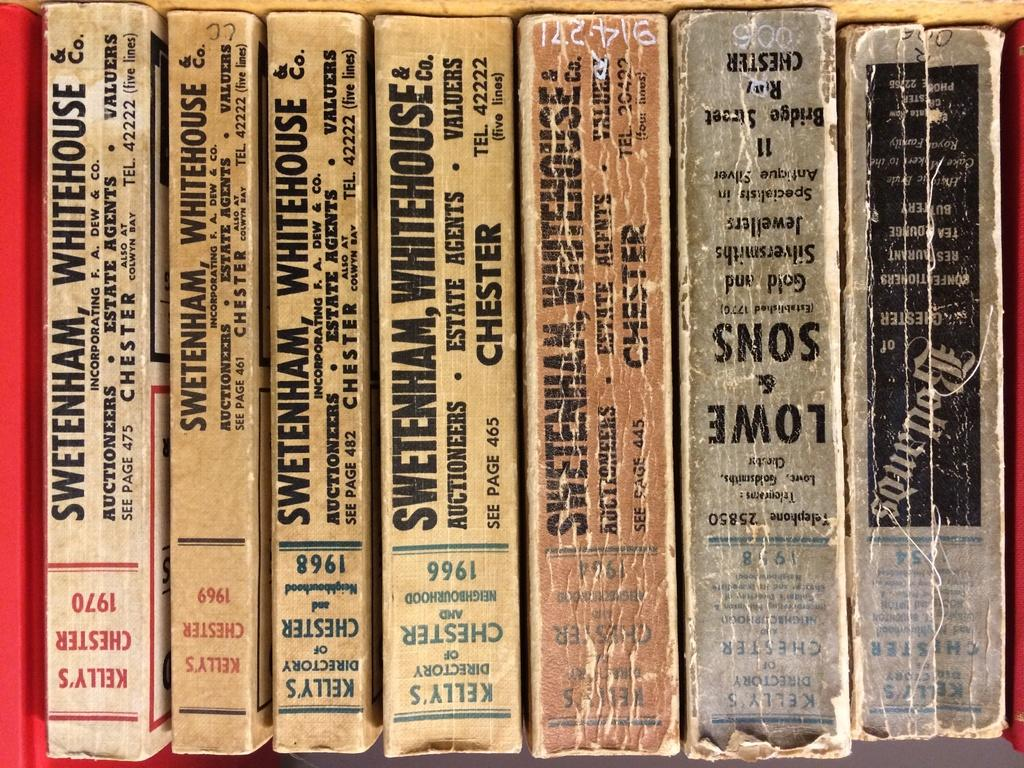What objects can be seen in the image? There are books in the image. What can be observed on the surface of the books? There is text visible on the books. How many cars are parked on the floor in the image? There are no cars or floors visible in the image; it only features books with text on them. 